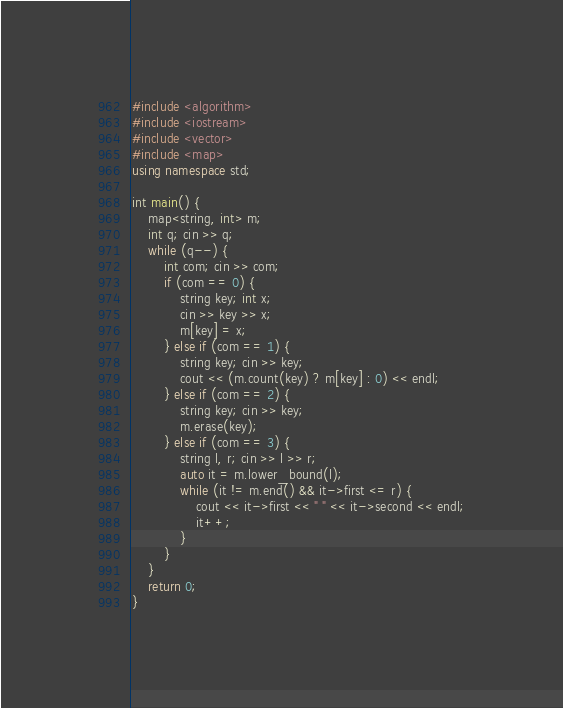<code> <loc_0><loc_0><loc_500><loc_500><_C++_>#include <algorithm>
#include <iostream>
#include <vector>
#include <map>
using namespace std;

int main() {
    map<string, int> m;
    int q; cin >> q;
    while (q--) {
        int com; cin >> com;
        if (com == 0) {
            string key; int x;
            cin >> key >> x;
            m[key] = x;
        } else if (com == 1) {
            string key; cin >> key;
            cout << (m.count(key) ? m[key] : 0) << endl;
        } else if (com == 2) {
            string key; cin >> key;
            m.erase(key);
        } else if (com == 3) {
            string l, r; cin >> l >> r;
            auto it = m.lower_bound(l);
            while (it != m.end() && it->first <= r) {
                cout << it->first << " " << it->second << endl;
                it++;
            }
        }
    }
    return 0;
}
</code> 